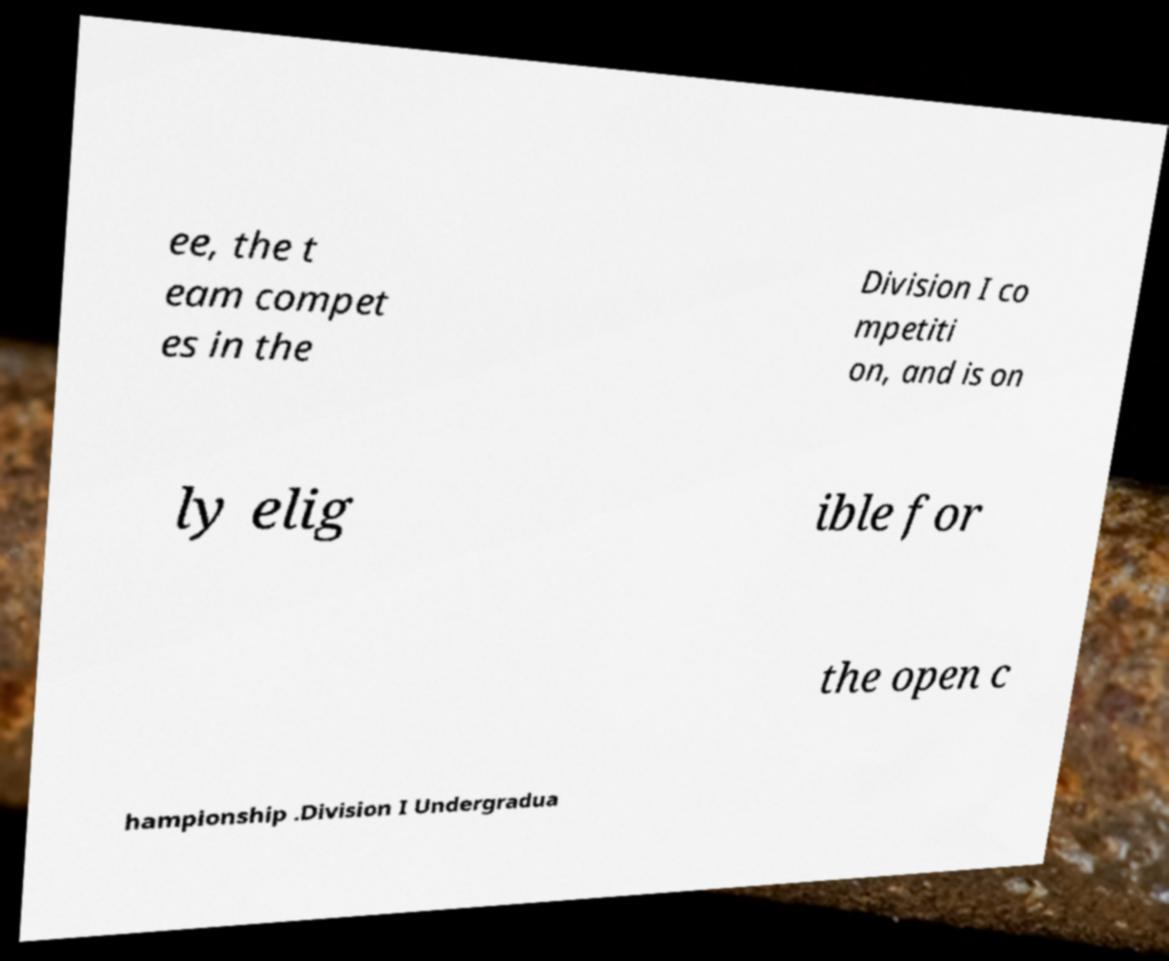Could you assist in decoding the text presented in this image and type it out clearly? ee, the t eam compet es in the Division I co mpetiti on, and is on ly elig ible for the open c hampionship .Division I Undergradua 